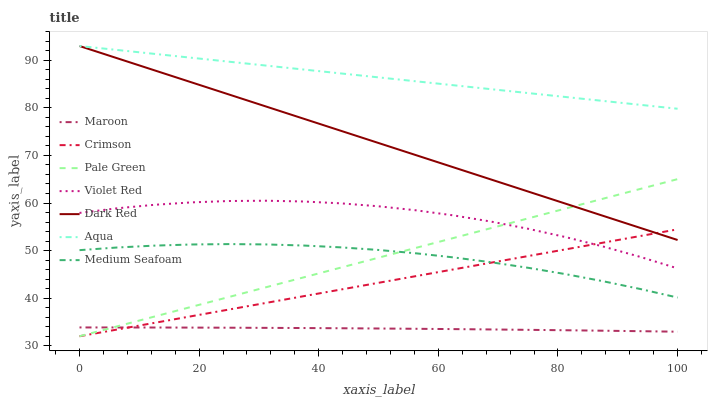Does Maroon have the minimum area under the curve?
Answer yes or no. Yes. Does Aqua have the maximum area under the curve?
Answer yes or no. Yes. Does Dark Red have the minimum area under the curve?
Answer yes or no. No. Does Dark Red have the maximum area under the curve?
Answer yes or no. No. Is Crimson the smoothest?
Answer yes or no. Yes. Is Violet Red the roughest?
Answer yes or no. Yes. Is Dark Red the smoothest?
Answer yes or no. No. Is Dark Red the roughest?
Answer yes or no. No. Does Pale Green have the lowest value?
Answer yes or no. Yes. Does Dark Red have the lowest value?
Answer yes or no. No. Does Aqua have the highest value?
Answer yes or no. Yes. Does Maroon have the highest value?
Answer yes or no. No. Is Violet Red less than Dark Red?
Answer yes or no. Yes. Is Aqua greater than Medium Seafoam?
Answer yes or no. Yes. Does Dark Red intersect Pale Green?
Answer yes or no. Yes. Is Dark Red less than Pale Green?
Answer yes or no. No. Is Dark Red greater than Pale Green?
Answer yes or no. No. Does Violet Red intersect Dark Red?
Answer yes or no. No. 